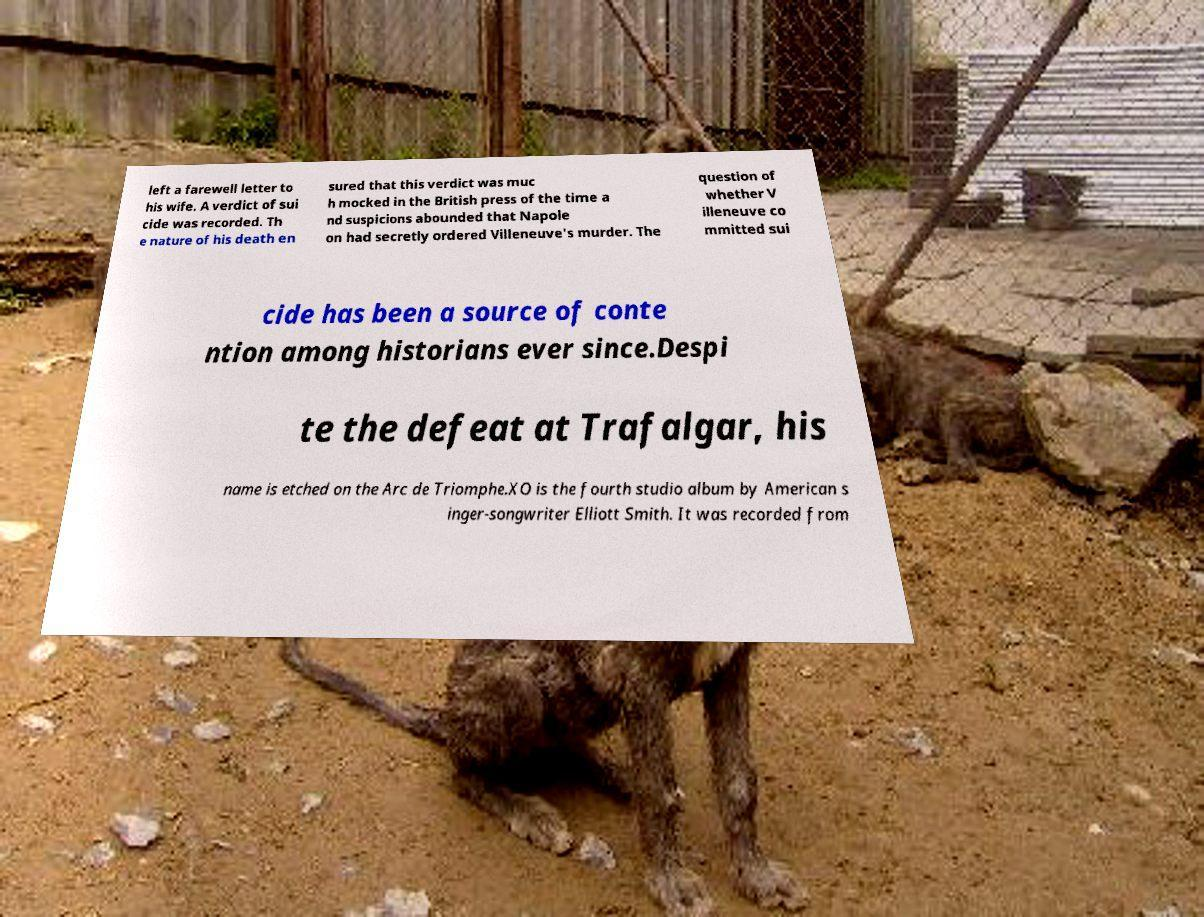I need the written content from this picture converted into text. Can you do that? left a farewell letter to his wife. A verdict of sui cide was recorded. Th e nature of his death en sured that this verdict was muc h mocked in the British press of the time a nd suspicions abounded that Napole on had secretly ordered Villeneuve's murder. The question of whether V illeneuve co mmitted sui cide has been a source of conte ntion among historians ever since.Despi te the defeat at Trafalgar, his name is etched on the Arc de Triomphe.XO is the fourth studio album by American s inger-songwriter Elliott Smith. It was recorded from 